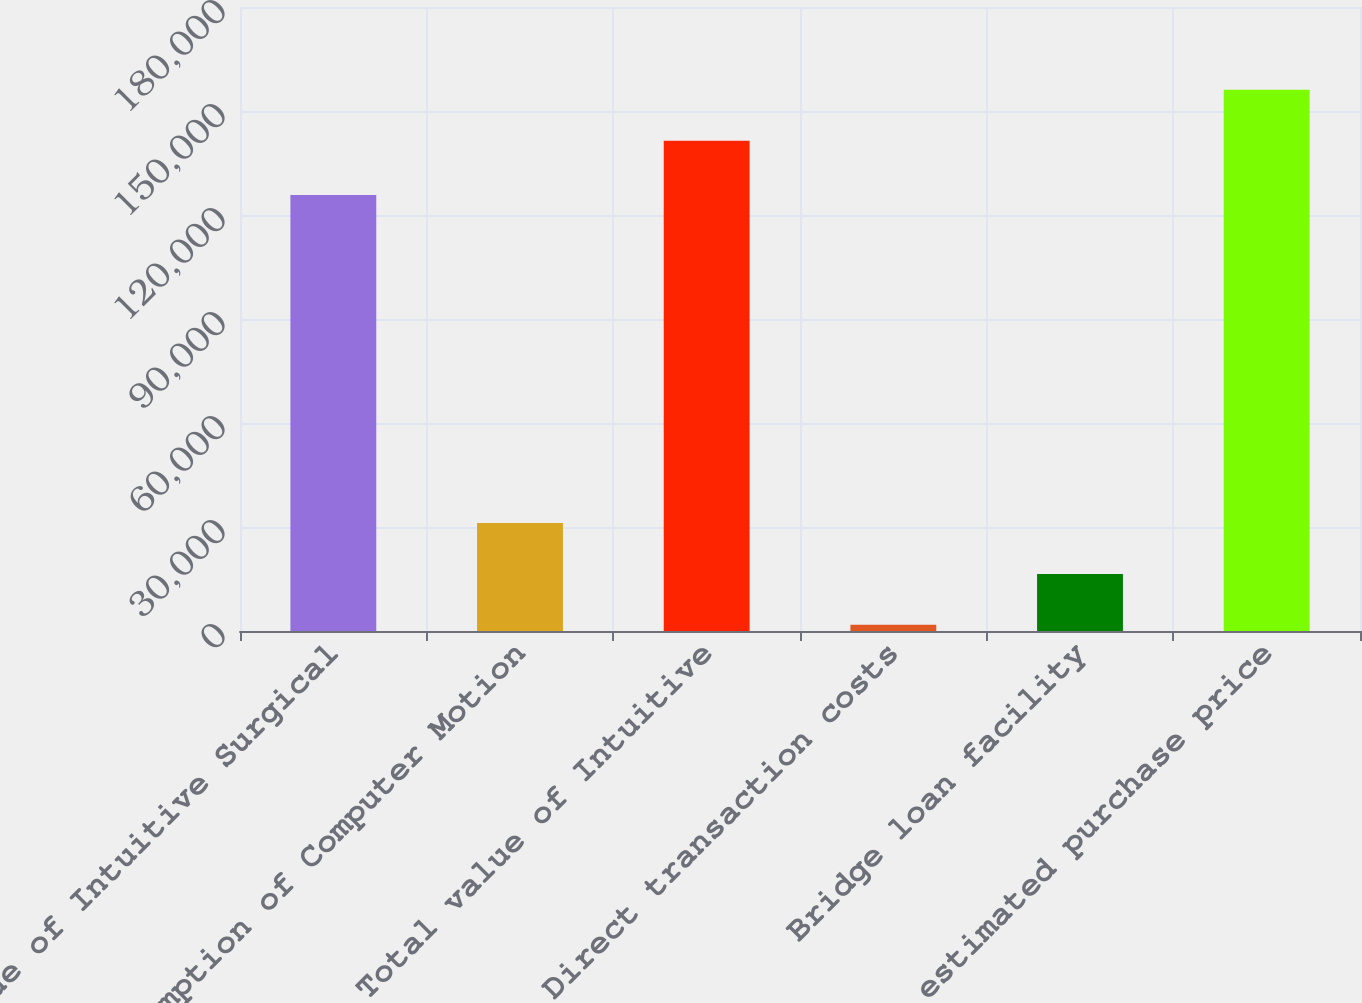Convert chart to OTSL. <chart><loc_0><loc_0><loc_500><loc_500><bar_chart><fcel>Value of Intuitive Surgical<fcel>Assumption of Computer Motion<fcel>Total value of Intuitive<fcel>Direct transaction costs<fcel>Bridge loan facility<fcel>Total estimated purchase price<nl><fcel>125734<fcel>31121.8<fcel>141437<fcel>1774<fcel>16447.9<fcel>156111<nl></chart> 